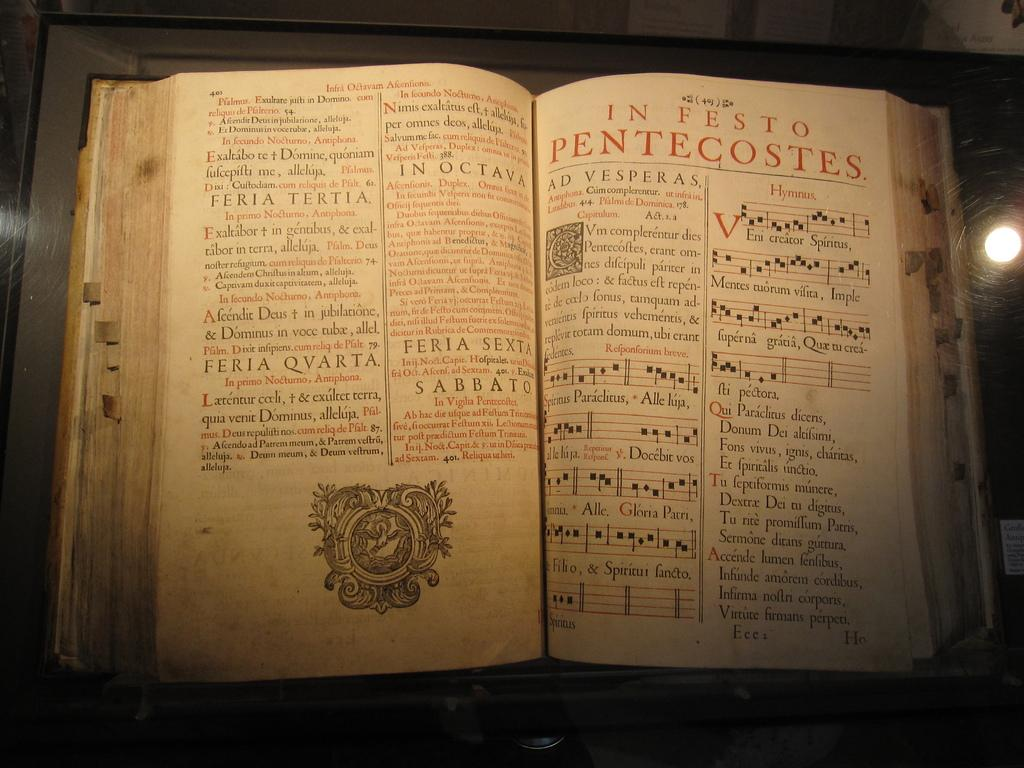<image>
Summarize the visual content of the image. the bible with the pentecostes book open with all its versicles 